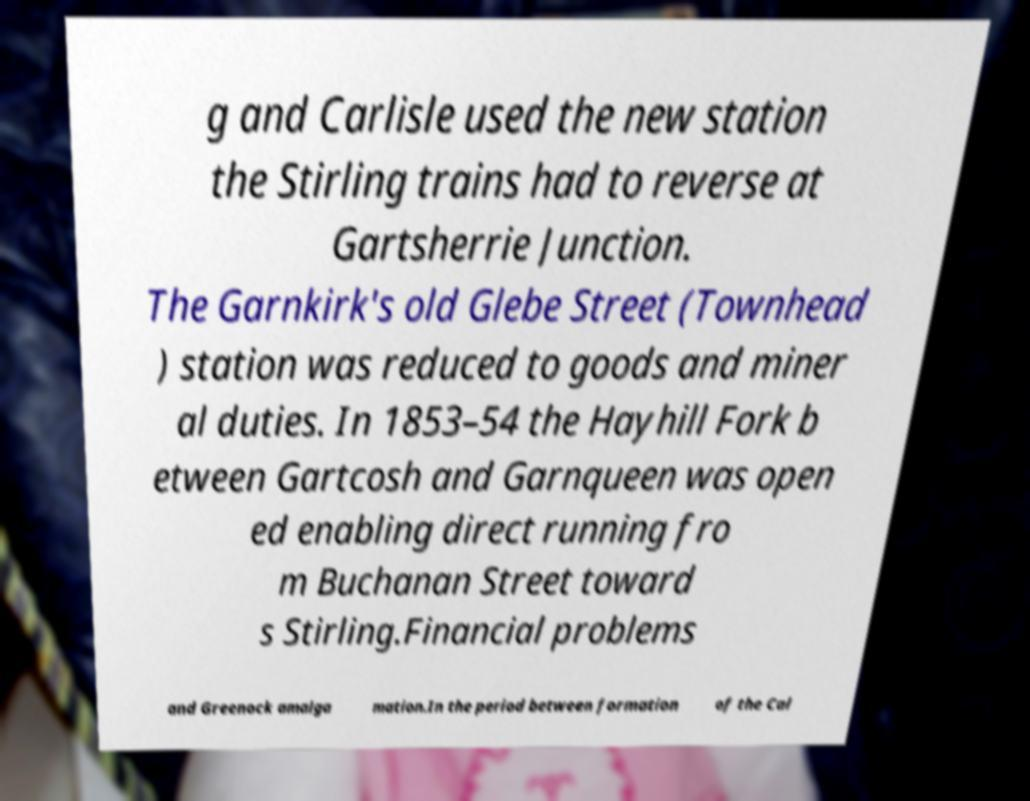For documentation purposes, I need the text within this image transcribed. Could you provide that? g and Carlisle used the new station the Stirling trains had to reverse at Gartsherrie Junction. The Garnkirk's old Glebe Street (Townhead ) station was reduced to goods and miner al duties. In 1853–54 the Hayhill Fork b etween Gartcosh and Garnqueen was open ed enabling direct running fro m Buchanan Street toward s Stirling.Financial problems and Greenock amalga mation.In the period between formation of the Cal 